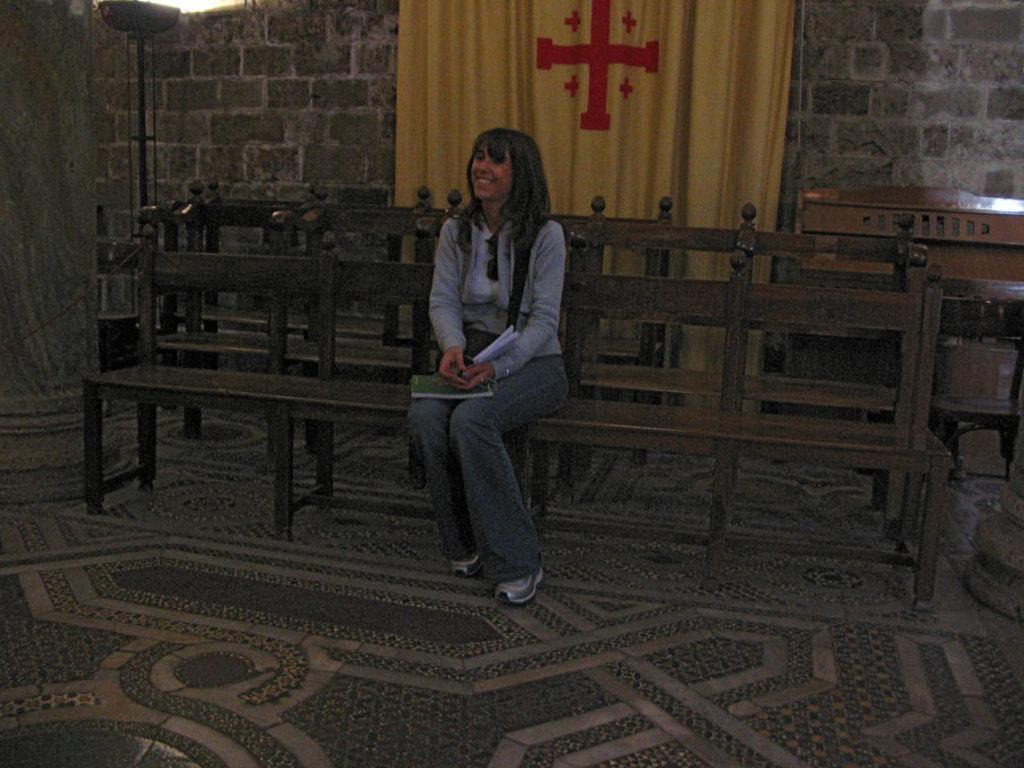Describe this image in one or two sentences. In this picture we can see a woman sitting on a bench. We can see a paper and a book on her lap. In the background we can see a yellow curtain and red symbols on it. On the left side we can see a light ray and a pillar. At the bottom we can see floor carpet on the floor. 